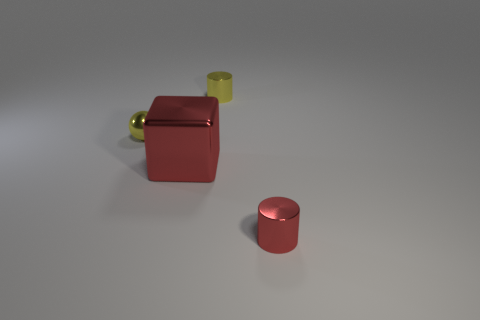Add 4 large metallic things. How many objects exist? 8 Subtract all balls. How many objects are left? 3 Subtract all tiny yellow things. Subtract all metal cylinders. How many objects are left? 0 Add 1 tiny red cylinders. How many tiny red cylinders are left? 2 Add 3 small cyan cylinders. How many small cyan cylinders exist? 3 Subtract 0 yellow blocks. How many objects are left? 4 